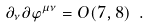Convert formula to latex. <formula><loc_0><loc_0><loc_500><loc_500>\partial _ { \nu } \partial \varphi ^ { \mu \nu } = O ( 7 , 8 ) \ .</formula> 